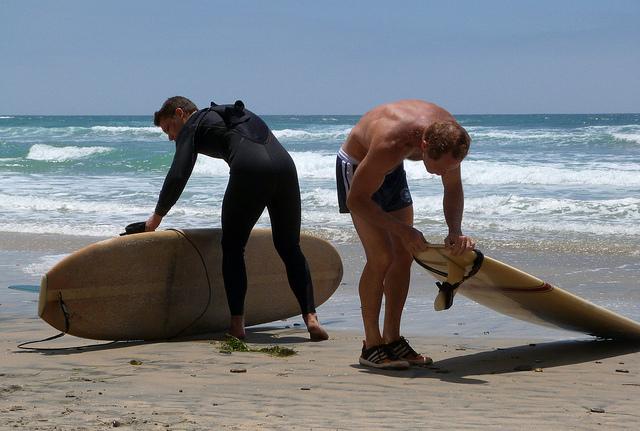How many surfboards?
Answer briefly. 2. Which of the two surfers is wearing a diving suit?
Concise answer only. Left. Are the men slaves to the surfboards?
Concise answer only. No. 